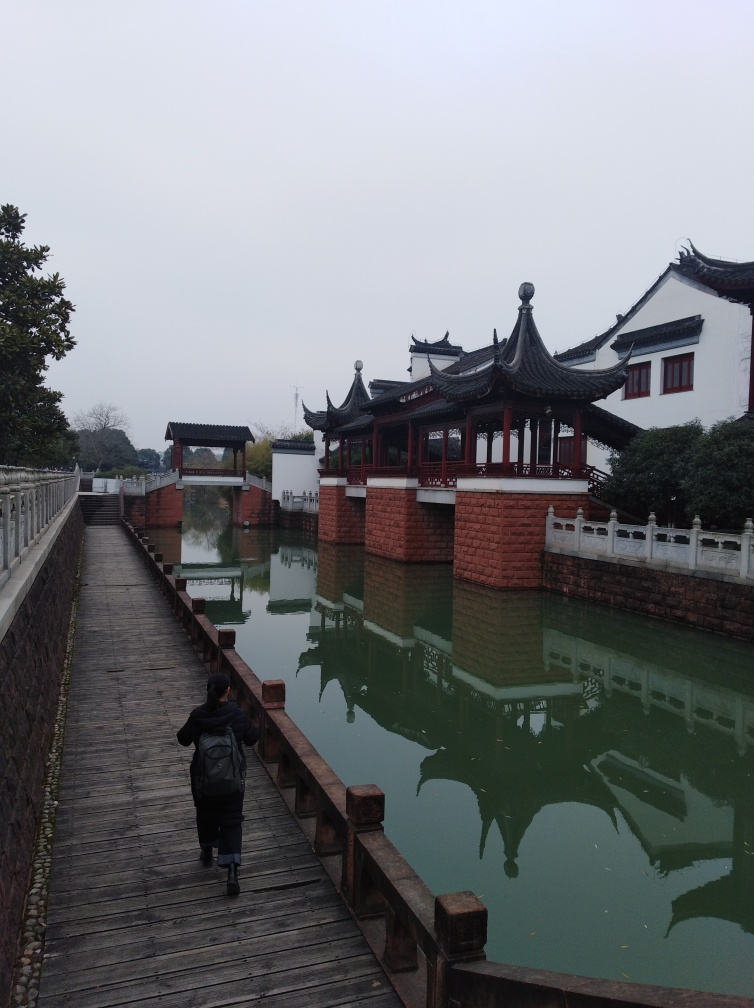What time of day does this image appear to have been taken? Considering the overcast sky and the soft lighting without harsh shadows, it seems like the photograph may have been taken either on a cloudy day or during the early hours after sunrise or before sunset. 